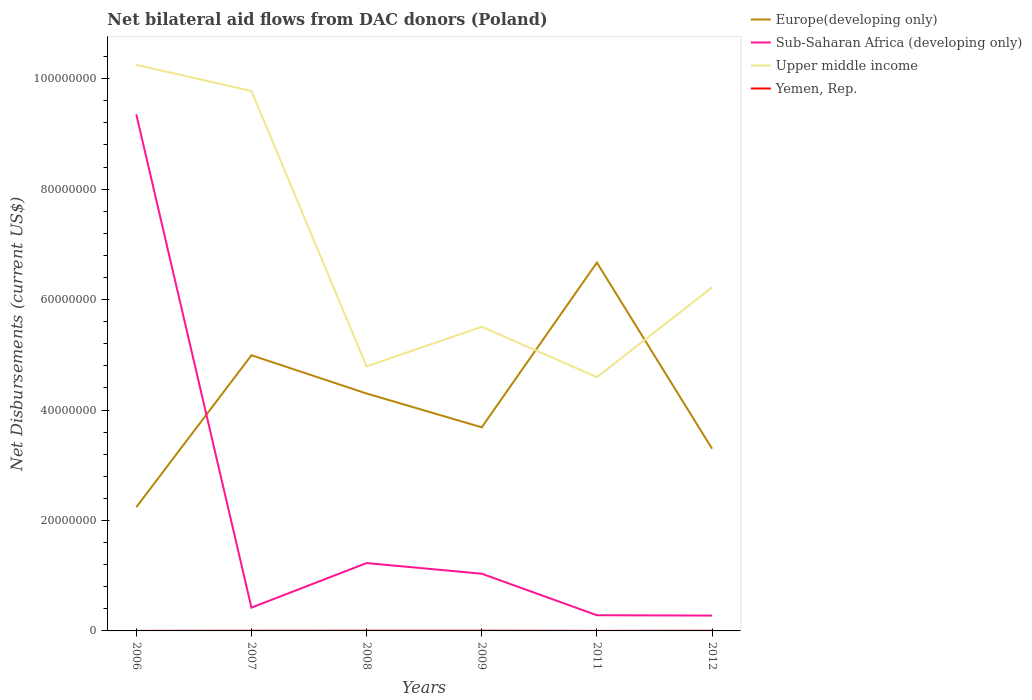How many different coloured lines are there?
Offer a very short reply. 4. Is the number of lines equal to the number of legend labels?
Offer a very short reply. Yes. Across all years, what is the maximum net bilateral aid flows in Sub-Saharan Africa (developing only)?
Your answer should be very brief. 2.78e+06. What is the total net bilateral aid flows in Europe(developing only) in the graph?
Offer a very short reply. -1.06e+07. What is the difference between the highest and the second highest net bilateral aid flows in Upper middle income?
Make the answer very short. 5.65e+07. Is the net bilateral aid flows in Sub-Saharan Africa (developing only) strictly greater than the net bilateral aid flows in Upper middle income over the years?
Ensure brevity in your answer.  Yes. How many lines are there?
Your answer should be compact. 4. What is the difference between two consecutive major ticks on the Y-axis?
Ensure brevity in your answer.  2.00e+07. Does the graph contain any zero values?
Your answer should be very brief. No. What is the title of the graph?
Offer a very short reply. Net bilateral aid flows from DAC donors (Poland). What is the label or title of the X-axis?
Offer a very short reply. Years. What is the label or title of the Y-axis?
Provide a succinct answer. Net Disbursements (current US$). What is the Net Disbursements (current US$) in Europe(developing only) in 2006?
Offer a very short reply. 2.24e+07. What is the Net Disbursements (current US$) in Sub-Saharan Africa (developing only) in 2006?
Provide a short and direct response. 9.35e+07. What is the Net Disbursements (current US$) of Upper middle income in 2006?
Your response must be concise. 1.02e+08. What is the Net Disbursements (current US$) in Europe(developing only) in 2007?
Provide a succinct answer. 4.99e+07. What is the Net Disbursements (current US$) of Sub-Saharan Africa (developing only) in 2007?
Your answer should be compact. 4.22e+06. What is the Net Disbursements (current US$) in Upper middle income in 2007?
Offer a terse response. 9.78e+07. What is the Net Disbursements (current US$) in Europe(developing only) in 2008?
Your answer should be compact. 4.30e+07. What is the Net Disbursements (current US$) in Sub-Saharan Africa (developing only) in 2008?
Offer a very short reply. 1.23e+07. What is the Net Disbursements (current US$) in Upper middle income in 2008?
Keep it short and to the point. 4.79e+07. What is the Net Disbursements (current US$) of Europe(developing only) in 2009?
Keep it short and to the point. 3.69e+07. What is the Net Disbursements (current US$) of Sub-Saharan Africa (developing only) in 2009?
Keep it short and to the point. 1.04e+07. What is the Net Disbursements (current US$) of Upper middle income in 2009?
Your answer should be very brief. 5.51e+07. What is the Net Disbursements (current US$) in Yemen, Rep. in 2009?
Offer a terse response. 4.00e+04. What is the Net Disbursements (current US$) of Europe(developing only) in 2011?
Provide a succinct answer. 6.67e+07. What is the Net Disbursements (current US$) in Sub-Saharan Africa (developing only) in 2011?
Offer a very short reply. 2.84e+06. What is the Net Disbursements (current US$) of Upper middle income in 2011?
Your answer should be very brief. 4.60e+07. What is the Net Disbursements (current US$) of Yemen, Rep. in 2011?
Offer a terse response. 10000. What is the Net Disbursements (current US$) of Europe(developing only) in 2012?
Make the answer very short. 3.30e+07. What is the Net Disbursements (current US$) of Sub-Saharan Africa (developing only) in 2012?
Provide a succinct answer. 2.78e+06. What is the Net Disbursements (current US$) of Upper middle income in 2012?
Your answer should be compact. 6.22e+07. What is the Net Disbursements (current US$) of Yemen, Rep. in 2012?
Make the answer very short. 3.00e+04. Across all years, what is the maximum Net Disbursements (current US$) of Europe(developing only)?
Offer a very short reply. 6.67e+07. Across all years, what is the maximum Net Disbursements (current US$) in Sub-Saharan Africa (developing only)?
Make the answer very short. 9.35e+07. Across all years, what is the maximum Net Disbursements (current US$) in Upper middle income?
Make the answer very short. 1.02e+08. Across all years, what is the minimum Net Disbursements (current US$) in Europe(developing only)?
Give a very brief answer. 2.24e+07. Across all years, what is the minimum Net Disbursements (current US$) in Sub-Saharan Africa (developing only)?
Offer a very short reply. 2.78e+06. Across all years, what is the minimum Net Disbursements (current US$) in Upper middle income?
Give a very brief answer. 4.60e+07. Across all years, what is the minimum Net Disbursements (current US$) in Yemen, Rep.?
Provide a short and direct response. 10000. What is the total Net Disbursements (current US$) of Europe(developing only) in the graph?
Your answer should be very brief. 2.52e+08. What is the total Net Disbursements (current US$) in Sub-Saharan Africa (developing only) in the graph?
Provide a short and direct response. 1.26e+08. What is the total Net Disbursements (current US$) in Upper middle income in the graph?
Make the answer very short. 4.11e+08. What is the difference between the Net Disbursements (current US$) in Europe(developing only) in 2006 and that in 2007?
Keep it short and to the point. -2.75e+07. What is the difference between the Net Disbursements (current US$) of Sub-Saharan Africa (developing only) in 2006 and that in 2007?
Your response must be concise. 8.93e+07. What is the difference between the Net Disbursements (current US$) of Upper middle income in 2006 and that in 2007?
Give a very brief answer. 4.73e+06. What is the difference between the Net Disbursements (current US$) of Europe(developing only) in 2006 and that in 2008?
Your response must be concise. -2.06e+07. What is the difference between the Net Disbursements (current US$) in Sub-Saharan Africa (developing only) in 2006 and that in 2008?
Offer a very short reply. 8.12e+07. What is the difference between the Net Disbursements (current US$) of Upper middle income in 2006 and that in 2008?
Your response must be concise. 5.46e+07. What is the difference between the Net Disbursements (current US$) in Yemen, Rep. in 2006 and that in 2008?
Provide a succinct answer. -3.00e+04. What is the difference between the Net Disbursements (current US$) of Europe(developing only) in 2006 and that in 2009?
Give a very brief answer. -1.45e+07. What is the difference between the Net Disbursements (current US$) in Sub-Saharan Africa (developing only) in 2006 and that in 2009?
Provide a short and direct response. 8.32e+07. What is the difference between the Net Disbursements (current US$) in Upper middle income in 2006 and that in 2009?
Your response must be concise. 4.74e+07. What is the difference between the Net Disbursements (current US$) of Yemen, Rep. in 2006 and that in 2009?
Offer a terse response. -3.00e+04. What is the difference between the Net Disbursements (current US$) in Europe(developing only) in 2006 and that in 2011?
Provide a short and direct response. -4.43e+07. What is the difference between the Net Disbursements (current US$) of Sub-Saharan Africa (developing only) in 2006 and that in 2011?
Provide a succinct answer. 9.07e+07. What is the difference between the Net Disbursements (current US$) of Upper middle income in 2006 and that in 2011?
Give a very brief answer. 5.65e+07. What is the difference between the Net Disbursements (current US$) of Europe(developing only) in 2006 and that in 2012?
Your response must be concise. -1.06e+07. What is the difference between the Net Disbursements (current US$) of Sub-Saharan Africa (developing only) in 2006 and that in 2012?
Make the answer very short. 9.08e+07. What is the difference between the Net Disbursements (current US$) in Upper middle income in 2006 and that in 2012?
Give a very brief answer. 4.03e+07. What is the difference between the Net Disbursements (current US$) of Yemen, Rep. in 2006 and that in 2012?
Provide a succinct answer. -2.00e+04. What is the difference between the Net Disbursements (current US$) of Europe(developing only) in 2007 and that in 2008?
Your answer should be compact. 6.93e+06. What is the difference between the Net Disbursements (current US$) of Sub-Saharan Africa (developing only) in 2007 and that in 2008?
Offer a terse response. -8.07e+06. What is the difference between the Net Disbursements (current US$) in Upper middle income in 2007 and that in 2008?
Offer a terse response. 4.99e+07. What is the difference between the Net Disbursements (current US$) of Yemen, Rep. in 2007 and that in 2008?
Provide a succinct answer. -10000. What is the difference between the Net Disbursements (current US$) in Europe(developing only) in 2007 and that in 2009?
Give a very brief answer. 1.30e+07. What is the difference between the Net Disbursements (current US$) in Sub-Saharan Africa (developing only) in 2007 and that in 2009?
Ensure brevity in your answer.  -6.14e+06. What is the difference between the Net Disbursements (current US$) of Upper middle income in 2007 and that in 2009?
Provide a short and direct response. 4.27e+07. What is the difference between the Net Disbursements (current US$) of Europe(developing only) in 2007 and that in 2011?
Keep it short and to the point. -1.68e+07. What is the difference between the Net Disbursements (current US$) of Sub-Saharan Africa (developing only) in 2007 and that in 2011?
Make the answer very short. 1.38e+06. What is the difference between the Net Disbursements (current US$) of Upper middle income in 2007 and that in 2011?
Give a very brief answer. 5.18e+07. What is the difference between the Net Disbursements (current US$) in Europe(developing only) in 2007 and that in 2012?
Offer a terse response. 1.69e+07. What is the difference between the Net Disbursements (current US$) in Sub-Saharan Africa (developing only) in 2007 and that in 2012?
Ensure brevity in your answer.  1.44e+06. What is the difference between the Net Disbursements (current US$) in Upper middle income in 2007 and that in 2012?
Provide a short and direct response. 3.56e+07. What is the difference between the Net Disbursements (current US$) of Europe(developing only) in 2008 and that in 2009?
Your answer should be very brief. 6.12e+06. What is the difference between the Net Disbursements (current US$) of Sub-Saharan Africa (developing only) in 2008 and that in 2009?
Make the answer very short. 1.93e+06. What is the difference between the Net Disbursements (current US$) of Upper middle income in 2008 and that in 2009?
Ensure brevity in your answer.  -7.17e+06. What is the difference between the Net Disbursements (current US$) of Europe(developing only) in 2008 and that in 2011?
Ensure brevity in your answer.  -2.37e+07. What is the difference between the Net Disbursements (current US$) of Sub-Saharan Africa (developing only) in 2008 and that in 2011?
Your response must be concise. 9.45e+06. What is the difference between the Net Disbursements (current US$) of Upper middle income in 2008 and that in 2011?
Provide a short and direct response. 1.94e+06. What is the difference between the Net Disbursements (current US$) in Yemen, Rep. in 2008 and that in 2011?
Keep it short and to the point. 3.00e+04. What is the difference between the Net Disbursements (current US$) in Europe(developing only) in 2008 and that in 2012?
Give a very brief answer. 9.99e+06. What is the difference between the Net Disbursements (current US$) in Sub-Saharan Africa (developing only) in 2008 and that in 2012?
Offer a very short reply. 9.51e+06. What is the difference between the Net Disbursements (current US$) of Upper middle income in 2008 and that in 2012?
Your response must be concise. -1.43e+07. What is the difference between the Net Disbursements (current US$) in Yemen, Rep. in 2008 and that in 2012?
Offer a terse response. 10000. What is the difference between the Net Disbursements (current US$) in Europe(developing only) in 2009 and that in 2011?
Offer a terse response. -2.98e+07. What is the difference between the Net Disbursements (current US$) in Sub-Saharan Africa (developing only) in 2009 and that in 2011?
Make the answer very short. 7.52e+06. What is the difference between the Net Disbursements (current US$) of Upper middle income in 2009 and that in 2011?
Provide a succinct answer. 9.11e+06. What is the difference between the Net Disbursements (current US$) of Europe(developing only) in 2009 and that in 2012?
Your answer should be compact. 3.87e+06. What is the difference between the Net Disbursements (current US$) in Sub-Saharan Africa (developing only) in 2009 and that in 2012?
Offer a very short reply. 7.58e+06. What is the difference between the Net Disbursements (current US$) of Upper middle income in 2009 and that in 2012?
Provide a short and direct response. -7.13e+06. What is the difference between the Net Disbursements (current US$) in Europe(developing only) in 2011 and that in 2012?
Give a very brief answer. 3.37e+07. What is the difference between the Net Disbursements (current US$) in Sub-Saharan Africa (developing only) in 2011 and that in 2012?
Your response must be concise. 6.00e+04. What is the difference between the Net Disbursements (current US$) in Upper middle income in 2011 and that in 2012?
Give a very brief answer. -1.62e+07. What is the difference between the Net Disbursements (current US$) in Yemen, Rep. in 2011 and that in 2012?
Provide a succinct answer. -2.00e+04. What is the difference between the Net Disbursements (current US$) in Europe(developing only) in 2006 and the Net Disbursements (current US$) in Sub-Saharan Africa (developing only) in 2007?
Give a very brief answer. 1.82e+07. What is the difference between the Net Disbursements (current US$) of Europe(developing only) in 2006 and the Net Disbursements (current US$) of Upper middle income in 2007?
Provide a short and direct response. -7.54e+07. What is the difference between the Net Disbursements (current US$) in Europe(developing only) in 2006 and the Net Disbursements (current US$) in Yemen, Rep. in 2007?
Your answer should be very brief. 2.24e+07. What is the difference between the Net Disbursements (current US$) in Sub-Saharan Africa (developing only) in 2006 and the Net Disbursements (current US$) in Upper middle income in 2007?
Give a very brief answer. -4.23e+06. What is the difference between the Net Disbursements (current US$) in Sub-Saharan Africa (developing only) in 2006 and the Net Disbursements (current US$) in Yemen, Rep. in 2007?
Your answer should be compact. 9.35e+07. What is the difference between the Net Disbursements (current US$) of Upper middle income in 2006 and the Net Disbursements (current US$) of Yemen, Rep. in 2007?
Your answer should be compact. 1.02e+08. What is the difference between the Net Disbursements (current US$) of Europe(developing only) in 2006 and the Net Disbursements (current US$) of Sub-Saharan Africa (developing only) in 2008?
Your response must be concise. 1.01e+07. What is the difference between the Net Disbursements (current US$) of Europe(developing only) in 2006 and the Net Disbursements (current US$) of Upper middle income in 2008?
Your answer should be compact. -2.55e+07. What is the difference between the Net Disbursements (current US$) in Europe(developing only) in 2006 and the Net Disbursements (current US$) in Yemen, Rep. in 2008?
Offer a terse response. 2.24e+07. What is the difference between the Net Disbursements (current US$) in Sub-Saharan Africa (developing only) in 2006 and the Net Disbursements (current US$) in Upper middle income in 2008?
Ensure brevity in your answer.  4.56e+07. What is the difference between the Net Disbursements (current US$) in Sub-Saharan Africa (developing only) in 2006 and the Net Disbursements (current US$) in Yemen, Rep. in 2008?
Provide a short and direct response. 9.35e+07. What is the difference between the Net Disbursements (current US$) in Upper middle income in 2006 and the Net Disbursements (current US$) in Yemen, Rep. in 2008?
Provide a succinct answer. 1.02e+08. What is the difference between the Net Disbursements (current US$) of Europe(developing only) in 2006 and the Net Disbursements (current US$) of Sub-Saharan Africa (developing only) in 2009?
Offer a terse response. 1.20e+07. What is the difference between the Net Disbursements (current US$) in Europe(developing only) in 2006 and the Net Disbursements (current US$) in Upper middle income in 2009?
Give a very brief answer. -3.27e+07. What is the difference between the Net Disbursements (current US$) of Europe(developing only) in 2006 and the Net Disbursements (current US$) of Yemen, Rep. in 2009?
Your answer should be very brief. 2.24e+07. What is the difference between the Net Disbursements (current US$) of Sub-Saharan Africa (developing only) in 2006 and the Net Disbursements (current US$) of Upper middle income in 2009?
Ensure brevity in your answer.  3.85e+07. What is the difference between the Net Disbursements (current US$) in Sub-Saharan Africa (developing only) in 2006 and the Net Disbursements (current US$) in Yemen, Rep. in 2009?
Keep it short and to the point. 9.35e+07. What is the difference between the Net Disbursements (current US$) in Upper middle income in 2006 and the Net Disbursements (current US$) in Yemen, Rep. in 2009?
Make the answer very short. 1.02e+08. What is the difference between the Net Disbursements (current US$) of Europe(developing only) in 2006 and the Net Disbursements (current US$) of Sub-Saharan Africa (developing only) in 2011?
Your response must be concise. 1.96e+07. What is the difference between the Net Disbursements (current US$) of Europe(developing only) in 2006 and the Net Disbursements (current US$) of Upper middle income in 2011?
Your answer should be compact. -2.36e+07. What is the difference between the Net Disbursements (current US$) in Europe(developing only) in 2006 and the Net Disbursements (current US$) in Yemen, Rep. in 2011?
Ensure brevity in your answer.  2.24e+07. What is the difference between the Net Disbursements (current US$) in Sub-Saharan Africa (developing only) in 2006 and the Net Disbursements (current US$) in Upper middle income in 2011?
Your answer should be very brief. 4.76e+07. What is the difference between the Net Disbursements (current US$) of Sub-Saharan Africa (developing only) in 2006 and the Net Disbursements (current US$) of Yemen, Rep. in 2011?
Your answer should be compact. 9.35e+07. What is the difference between the Net Disbursements (current US$) in Upper middle income in 2006 and the Net Disbursements (current US$) in Yemen, Rep. in 2011?
Provide a succinct answer. 1.02e+08. What is the difference between the Net Disbursements (current US$) in Europe(developing only) in 2006 and the Net Disbursements (current US$) in Sub-Saharan Africa (developing only) in 2012?
Your response must be concise. 1.96e+07. What is the difference between the Net Disbursements (current US$) of Europe(developing only) in 2006 and the Net Disbursements (current US$) of Upper middle income in 2012?
Your answer should be very brief. -3.98e+07. What is the difference between the Net Disbursements (current US$) of Europe(developing only) in 2006 and the Net Disbursements (current US$) of Yemen, Rep. in 2012?
Your answer should be compact. 2.24e+07. What is the difference between the Net Disbursements (current US$) in Sub-Saharan Africa (developing only) in 2006 and the Net Disbursements (current US$) in Upper middle income in 2012?
Provide a succinct answer. 3.13e+07. What is the difference between the Net Disbursements (current US$) of Sub-Saharan Africa (developing only) in 2006 and the Net Disbursements (current US$) of Yemen, Rep. in 2012?
Keep it short and to the point. 9.35e+07. What is the difference between the Net Disbursements (current US$) of Upper middle income in 2006 and the Net Disbursements (current US$) of Yemen, Rep. in 2012?
Make the answer very short. 1.02e+08. What is the difference between the Net Disbursements (current US$) in Europe(developing only) in 2007 and the Net Disbursements (current US$) in Sub-Saharan Africa (developing only) in 2008?
Make the answer very short. 3.76e+07. What is the difference between the Net Disbursements (current US$) in Europe(developing only) in 2007 and the Net Disbursements (current US$) in Upper middle income in 2008?
Your answer should be compact. 2.02e+06. What is the difference between the Net Disbursements (current US$) in Europe(developing only) in 2007 and the Net Disbursements (current US$) in Yemen, Rep. in 2008?
Provide a short and direct response. 4.99e+07. What is the difference between the Net Disbursements (current US$) of Sub-Saharan Africa (developing only) in 2007 and the Net Disbursements (current US$) of Upper middle income in 2008?
Ensure brevity in your answer.  -4.37e+07. What is the difference between the Net Disbursements (current US$) in Sub-Saharan Africa (developing only) in 2007 and the Net Disbursements (current US$) in Yemen, Rep. in 2008?
Provide a short and direct response. 4.18e+06. What is the difference between the Net Disbursements (current US$) in Upper middle income in 2007 and the Net Disbursements (current US$) in Yemen, Rep. in 2008?
Keep it short and to the point. 9.77e+07. What is the difference between the Net Disbursements (current US$) of Europe(developing only) in 2007 and the Net Disbursements (current US$) of Sub-Saharan Africa (developing only) in 2009?
Provide a succinct answer. 3.96e+07. What is the difference between the Net Disbursements (current US$) of Europe(developing only) in 2007 and the Net Disbursements (current US$) of Upper middle income in 2009?
Give a very brief answer. -5.15e+06. What is the difference between the Net Disbursements (current US$) of Europe(developing only) in 2007 and the Net Disbursements (current US$) of Yemen, Rep. in 2009?
Provide a succinct answer. 4.99e+07. What is the difference between the Net Disbursements (current US$) in Sub-Saharan Africa (developing only) in 2007 and the Net Disbursements (current US$) in Upper middle income in 2009?
Offer a very short reply. -5.08e+07. What is the difference between the Net Disbursements (current US$) in Sub-Saharan Africa (developing only) in 2007 and the Net Disbursements (current US$) in Yemen, Rep. in 2009?
Offer a terse response. 4.18e+06. What is the difference between the Net Disbursements (current US$) of Upper middle income in 2007 and the Net Disbursements (current US$) of Yemen, Rep. in 2009?
Give a very brief answer. 9.77e+07. What is the difference between the Net Disbursements (current US$) in Europe(developing only) in 2007 and the Net Disbursements (current US$) in Sub-Saharan Africa (developing only) in 2011?
Ensure brevity in your answer.  4.71e+07. What is the difference between the Net Disbursements (current US$) of Europe(developing only) in 2007 and the Net Disbursements (current US$) of Upper middle income in 2011?
Provide a succinct answer. 3.96e+06. What is the difference between the Net Disbursements (current US$) in Europe(developing only) in 2007 and the Net Disbursements (current US$) in Yemen, Rep. in 2011?
Provide a short and direct response. 4.99e+07. What is the difference between the Net Disbursements (current US$) in Sub-Saharan Africa (developing only) in 2007 and the Net Disbursements (current US$) in Upper middle income in 2011?
Offer a terse response. -4.17e+07. What is the difference between the Net Disbursements (current US$) in Sub-Saharan Africa (developing only) in 2007 and the Net Disbursements (current US$) in Yemen, Rep. in 2011?
Give a very brief answer. 4.21e+06. What is the difference between the Net Disbursements (current US$) in Upper middle income in 2007 and the Net Disbursements (current US$) in Yemen, Rep. in 2011?
Offer a very short reply. 9.78e+07. What is the difference between the Net Disbursements (current US$) in Europe(developing only) in 2007 and the Net Disbursements (current US$) in Sub-Saharan Africa (developing only) in 2012?
Your answer should be compact. 4.71e+07. What is the difference between the Net Disbursements (current US$) in Europe(developing only) in 2007 and the Net Disbursements (current US$) in Upper middle income in 2012?
Offer a very short reply. -1.23e+07. What is the difference between the Net Disbursements (current US$) of Europe(developing only) in 2007 and the Net Disbursements (current US$) of Yemen, Rep. in 2012?
Ensure brevity in your answer.  4.99e+07. What is the difference between the Net Disbursements (current US$) of Sub-Saharan Africa (developing only) in 2007 and the Net Disbursements (current US$) of Upper middle income in 2012?
Offer a terse response. -5.80e+07. What is the difference between the Net Disbursements (current US$) in Sub-Saharan Africa (developing only) in 2007 and the Net Disbursements (current US$) in Yemen, Rep. in 2012?
Your answer should be compact. 4.19e+06. What is the difference between the Net Disbursements (current US$) of Upper middle income in 2007 and the Net Disbursements (current US$) of Yemen, Rep. in 2012?
Your response must be concise. 9.77e+07. What is the difference between the Net Disbursements (current US$) of Europe(developing only) in 2008 and the Net Disbursements (current US$) of Sub-Saharan Africa (developing only) in 2009?
Your answer should be very brief. 3.26e+07. What is the difference between the Net Disbursements (current US$) in Europe(developing only) in 2008 and the Net Disbursements (current US$) in Upper middle income in 2009?
Make the answer very short. -1.21e+07. What is the difference between the Net Disbursements (current US$) of Europe(developing only) in 2008 and the Net Disbursements (current US$) of Yemen, Rep. in 2009?
Your answer should be very brief. 4.30e+07. What is the difference between the Net Disbursements (current US$) of Sub-Saharan Africa (developing only) in 2008 and the Net Disbursements (current US$) of Upper middle income in 2009?
Your answer should be very brief. -4.28e+07. What is the difference between the Net Disbursements (current US$) in Sub-Saharan Africa (developing only) in 2008 and the Net Disbursements (current US$) in Yemen, Rep. in 2009?
Make the answer very short. 1.22e+07. What is the difference between the Net Disbursements (current US$) of Upper middle income in 2008 and the Net Disbursements (current US$) of Yemen, Rep. in 2009?
Provide a short and direct response. 4.79e+07. What is the difference between the Net Disbursements (current US$) of Europe(developing only) in 2008 and the Net Disbursements (current US$) of Sub-Saharan Africa (developing only) in 2011?
Offer a very short reply. 4.02e+07. What is the difference between the Net Disbursements (current US$) of Europe(developing only) in 2008 and the Net Disbursements (current US$) of Upper middle income in 2011?
Your response must be concise. -2.97e+06. What is the difference between the Net Disbursements (current US$) in Europe(developing only) in 2008 and the Net Disbursements (current US$) in Yemen, Rep. in 2011?
Your response must be concise. 4.30e+07. What is the difference between the Net Disbursements (current US$) of Sub-Saharan Africa (developing only) in 2008 and the Net Disbursements (current US$) of Upper middle income in 2011?
Give a very brief answer. -3.37e+07. What is the difference between the Net Disbursements (current US$) in Sub-Saharan Africa (developing only) in 2008 and the Net Disbursements (current US$) in Yemen, Rep. in 2011?
Provide a short and direct response. 1.23e+07. What is the difference between the Net Disbursements (current US$) of Upper middle income in 2008 and the Net Disbursements (current US$) of Yemen, Rep. in 2011?
Provide a succinct answer. 4.79e+07. What is the difference between the Net Disbursements (current US$) of Europe(developing only) in 2008 and the Net Disbursements (current US$) of Sub-Saharan Africa (developing only) in 2012?
Make the answer very short. 4.02e+07. What is the difference between the Net Disbursements (current US$) in Europe(developing only) in 2008 and the Net Disbursements (current US$) in Upper middle income in 2012?
Provide a short and direct response. -1.92e+07. What is the difference between the Net Disbursements (current US$) in Europe(developing only) in 2008 and the Net Disbursements (current US$) in Yemen, Rep. in 2012?
Provide a succinct answer. 4.30e+07. What is the difference between the Net Disbursements (current US$) in Sub-Saharan Africa (developing only) in 2008 and the Net Disbursements (current US$) in Upper middle income in 2012?
Provide a succinct answer. -4.99e+07. What is the difference between the Net Disbursements (current US$) in Sub-Saharan Africa (developing only) in 2008 and the Net Disbursements (current US$) in Yemen, Rep. in 2012?
Your answer should be compact. 1.23e+07. What is the difference between the Net Disbursements (current US$) in Upper middle income in 2008 and the Net Disbursements (current US$) in Yemen, Rep. in 2012?
Provide a short and direct response. 4.79e+07. What is the difference between the Net Disbursements (current US$) of Europe(developing only) in 2009 and the Net Disbursements (current US$) of Sub-Saharan Africa (developing only) in 2011?
Ensure brevity in your answer.  3.40e+07. What is the difference between the Net Disbursements (current US$) in Europe(developing only) in 2009 and the Net Disbursements (current US$) in Upper middle income in 2011?
Provide a succinct answer. -9.09e+06. What is the difference between the Net Disbursements (current US$) of Europe(developing only) in 2009 and the Net Disbursements (current US$) of Yemen, Rep. in 2011?
Ensure brevity in your answer.  3.69e+07. What is the difference between the Net Disbursements (current US$) in Sub-Saharan Africa (developing only) in 2009 and the Net Disbursements (current US$) in Upper middle income in 2011?
Offer a terse response. -3.56e+07. What is the difference between the Net Disbursements (current US$) in Sub-Saharan Africa (developing only) in 2009 and the Net Disbursements (current US$) in Yemen, Rep. in 2011?
Make the answer very short. 1.04e+07. What is the difference between the Net Disbursements (current US$) of Upper middle income in 2009 and the Net Disbursements (current US$) of Yemen, Rep. in 2011?
Give a very brief answer. 5.51e+07. What is the difference between the Net Disbursements (current US$) in Europe(developing only) in 2009 and the Net Disbursements (current US$) in Sub-Saharan Africa (developing only) in 2012?
Provide a succinct answer. 3.41e+07. What is the difference between the Net Disbursements (current US$) in Europe(developing only) in 2009 and the Net Disbursements (current US$) in Upper middle income in 2012?
Keep it short and to the point. -2.53e+07. What is the difference between the Net Disbursements (current US$) of Europe(developing only) in 2009 and the Net Disbursements (current US$) of Yemen, Rep. in 2012?
Ensure brevity in your answer.  3.68e+07. What is the difference between the Net Disbursements (current US$) of Sub-Saharan Africa (developing only) in 2009 and the Net Disbursements (current US$) of Upper middle income in 2012?
Give a very brief answer. -5.18e+07. What is the difference between the Net Disbursements (current US$) of Sub-Saharan Africa (developing only) in 2009 and the Net Disbursements (current US$) of Yemen, Rep. in 2012?
Keep it short and to the point. 1.03e+07. What is the difference between the Net Disbursements (current US$) of Upper middle income in 2009 and the Net Disbursements (current US$) of Yemen, Rep. in 2012?
Provide a succinct answer. 5.50e+07. What is the difference between the Net Disbursements (current US$) in Europe(developing only) in 2011 and the Net Disbursements (current US$) in Sub-Saharan Africa (developing only) in 2012?
Offer a very short reply. 6.39e+07. What is the difference between the Net Disbursements (current US$) of Europe(developing only) in 2011 and the Net Disbursements (current US$) of Upper middle income in 2012?
Offer a very short reply. 4.50e+06. What is the difference between the Net Disbursements (current US$) of Europe(developing only) in 2011 and the Net Disbursements (current US$) of Yemen, Rep. in 2012?
Your response must be concise. 6.67e+07. What is the difference between the Net Disbursements (current US$) in Sub-Saharan Africa (developing only) in 2011 and the Net Disbursements (current US$) in Upper middle income in 2012?
Provide a succinct answer. -5.94e+07. What is the difference between the Net Disbursements (current US$) in Sub-Saharan Africa (developing only) in 2011 and the Net Disbursements (current US$) in Yemen, Rep. in 2012?
Your response must be concise. 2.81e+06. What is the difference between the Net Disbursements (current US$) in Upper middle income in 2011 and the Net Disbursements (current US$) in Yemen, Rep. in 2012?
Ensure brevity in your answer.  4.59e+07. What is the average Net Disbursements (current US$) of Europe(developing only) per year?
Your answer should be compact. 4.20e+07. What is the average Net Disbursements (current US$) of Sub-Saharan Africa (developing only) per year?
Give a very brief answer. 2.10e+07. What is the average Net Disbursements (current US$) in Upper middle income per year?
Provide a short and direct response. 6.86e+07. What is the average Net Disbursements (current US$) of Yemen, Rep. per year?
Provide a short and direct response. 2.67e+04. In the year 2006, what is the difference between the Net Disbursements (current US$) in Europe(developing only) and Net Disbursements (current US$) in Sub-Saharan Africa (developing only)?
Keep it short and to the point. -7.11e+07. In the year 2006, what is the difference between the Net Disbursements (current US$) in Europe(developing only) and Net Disbursements (current US$) in Upper middle income?
Your answer should be very brief. -8.01e+07. In the year 2006, what is the difference between the Net Disbursements (current US$) in Europe(developing only) and Net Disbursements (current US$) in Yemen, Rep.?
Keep it short and to the point. 2.24e+07. In the year 2006, what is the difference between the Net Disbursements (current US$) in Sub-Saharan Africa (developing only) and Net Disbursements (current US$) in Upper middle income?
Offer a terse response. -8.96e+06. In the year 2006, what is the difference between the Net Disbursements (current US$) in Sub-Saharan Africa (developing only) and Net Disbursements (current US$) in Yemen, Rep.?
Ensure brevity in your answer.  9.35e+07. In the year 2006, what is the difference between the Net Disbursements (current US$) of Upper middle income and Net Disbursements (current US$) of Yemen, Rep.?
Your answer should be compact. 1.02e+08. In the year 2007, what is the difference between the Net Disbursements (current US$) in Europe(developing only) and Net Disbursements (current US$) in Sub-Saharan Africa (developing only)?
Provide a succinct answer. 4.57e+07. In the year 2007, what is the difference between the Net Disbursements (current US$) of Europe(developing only) and Net Disbursements (current US$) of Upper middle income?
Your response must be concise. -4.78e+07. In the year 2007, what is the difference between the Net Disbursements (current US$) of Europe(developing only) and Net Disbursements (current US$) of Yemen, Rep.?
Ensure brevity in your answer.  4.99e+07. In the year 2007, what is the difference between the Net Disbursements (current US$) of Sub-Saharan Africa (developing only) and Net Disbursements (current US$) of Upper middle income?
Offer a very short reply. -9.36e+07. In the year 2007, what is the difference between the Net Disbursements (current US$) of Sub-Saharan Africa (developing only) and Net Disbursements (current US$) of Yemen, Rep.?
Your answer should be very brief. 4.19e+06. In the year 2007, what is the difference between the Net Disbursements (current US$) of Upper middle income and Net Disbursements (current US$) of Yemen, Rep.?
Give a very brief answer. 9.77e+07. In the year 2008, what is the difference between the Net Disbursements (current US$) of Europe(developing only) and Net Disbursements (current US$) of Sub-Saharan Africa (developing only)?
Ensure brevity in your answer.  3.07e+07. In the year 2008, what is the difference between the Net Disbursements (current US$) of Europe(developing only) and Net Disbursements (current US$) of Upper middle income?
Your answer should be very brief. -4.91e+06. In the year 2008, what is the difference between the Net Disbursements (current US$) in Europe(developing only) and Net Disbursements (current US$) in Yemen, Rep.?
Offer a terse response. 4.30e+07. In the year 2008, what is the difference between the Net Disbursements (current US$) of Sub-Saharan Africa (developing only) and Net Disbursements (current US$) of Upper middle income?
Provide a succinct answer. -3.56e+07. In the year 2008, what is the difference between the Net Disbursements (current US$) of Sub-Saharan Africa (developing only) and Net Disbursements (current US$) of Yemen, Rep.?
Keep it short and to the point. 1.22e+07. In the year 2008, what is the difference between the Net Disbursements (current US$) in Upper middle income and Net Disbursements (current US$) in Yemen, Rep.?
Provide a succinct answer. 4.79e+07. In the year 2009, what is the difference between the Net Disbursements (current US$) in Europe(developing only) and Net Disbursements (current US$) in Sub-Saharan Africa (developing only)?
Offer a terse response. 2.65e+07. In the year 2009, what is the difference between the Net Disbursements (current US$) of Europe(developing only) and Net Disbursements (current US$) of Upper middle income?
Your answer should be very brief. -1.82e+07. In the year 2009, what is the difference between the Net Disbursements (current US$) in Europe(developing only) and Net Disbursements (current US$) in Yemen, Rep.?
Keep it short and to the point. 3.68e+07. In the year 2009, what is the difference between the Net Disbursements (current US$) in Sub-Saharan Africa (developing only) and Net Disbursements (current US$) in Upper middle income?
Your response must be concise. -4.47e+07. In the year 2009, what is the difference between the Net Disbursements (current US$) in Sub-Saharan Africa (developing only) and Net Disbursements (current US$) in Yemen, Rep.?
Your answer should be compact. 1.03e+07. In the year 2009, what is the difference between the Net Disbursements (current US$) in Upper middle income and Net Disbursements (current US$) in Yemen, Rep.?
Offer a terse response. 5.50e+07. In the year 2011, what is the difference between the Net Disbursements (current US$) in Europe(developing only) and Net Disbursements (current US$) in Sub-Saharan Africa (developing only)?
Offer a very short reply. 6.39e+07. In the year 2011, what is the difference between the Net Disbursements (current US$) in Europe(developing only) and Net Disbursements (current US$) in Upper middle income?
Your answer should be very brief. 2.07e+07. In the year 2011, what is the difference between the Net Disbursements (current US$) in Europe(developing only) and Net Disbursements (current US$) in Yemen, Rep.?
Ensure brevity in your answer.  6.67e+07. In the year 2011, what is the difference between the Net Disbursements (current US$) in Sub-Saharan Africa (developing only) and Net Disbursements (current US$) in Upper middle income?
Your answer should be compact. -4.31e+07. In the year 2011, what is the difference between the Net Disbursements (current US$) in Sub-Saharan Africa (developing only) and Net Disbursements (current US$) in Yemen, Rep.?
Provide a short and direct response. 2.83e+06. In the year 2011, what is the difference between the Net Disbursements (current US$) of Upper middle income and Net Disbursements (current US$) of Yemen, Rep.?
Keep it short and to the point. 4.60e+07. In the year 2012, what is the difference between the Net Disbursements (current US$) in Europe(developing only) and Net Disbursements (current US$) in Sub-Saharan Africa (developing only)?
Your answer should be very brief. 3.02e+07. In the year 2012, what is the difference between the Net Disbursements (current US$) in Europe(developing only) and Net Disbursements (current US$) in Upper middle income?
Provide a short and direct response. -2.92e+07. In the year 2012, what is the difference between the Net Disbursements (current US$) in Europe(developing only) and Net Disbursements (current US$) in Yemen, Rep.?
Make the answer very short. 3.30e+07. In the year 2012, what is the difference between the Net Disbursements (current US$) of Sub-Saharan Africa (developing only) and Net Disbursements (current US$) of Upper middle income?
Give a very brief answer. -5.94e+07. In the year 2012, what is the difference between the Net Disbursements (current US$) of Sub-Saharan Africa (developing only) and Net Disbursements (current US$) of Yemen, Rep.?
Offer a very short reply. 2.75e+06. In the year 2012, what is the difference between the Net Disbursements (current US$) of Upper middle income and Net Disbursements (current US$) of Yemen, Rep.?
Ensure brevity in your answer.  6.22e+07. What is the ratio of the Net Disbursements (current US$) in Europe(developing only) in 2006 to that in 2007?
Provide a succinct answer. 0.45. What is the ratio of the Net Disbursements (current US$) of Sub-Saharan Africa (developing only) in 2006 to that in 2007?
Offer a very short reply. 22.17. What is the ratio of the Net Disbursements (current US$) of Upper middle income in 2006 to that in 2007?
Keep it short and to the point. 1.05. What is the ratio of the Net Disbursements (current US$) in Yemen, Rep. in 2006 to that in 2007?
Your response must be concise. 0.33. What is the ratio of the Net Disbursements (current US$) in Europe(developing only) in 2006 to that in 2008?
Keep it short and to the point. 0.52. What is the ratio of the Net Disbursements (current US$) in Sub-Saharan Africa (developing only) in 2006 to that in 2008?
Ensure brevity in your answer.  7.61. What is the ratio of the Net Disbursements (current US$) in Upper middle income in 2006 to that in 2008?
Offer a terse response. 2.14. What is the ratio of the Net Disbursements (current US$) in Europe(developing only) in 2006 to that in 2009?
Provide a short and direct response. 0.61. What is the ratio of the Net Disbursements (current US$) in Sub-Saharan Africa (developing only) in 2006 to that in 2009?
Your answer should be very brief. 9.03. What is the ratio of the Net Disbursements (current US$) of Upper middle income in 2006 to that in 2009?
Provide a succinct answer. 1.86. What is the ratio of the Net Disbursements (current US$) of Europe(developing only) in 2006 to that in 2011?
Provide a succinct answer. 0.34. What is the ratio of the Net Disbursements (current US$) in Sub-Saharan Africa (developing only) in 2006 to that in 2011?
Ensure brevity in your answer.  32.94. What is the ratio of the Net Disbursements (current US$) of Upper middle income in 2006 to that in 2011?
Give a very brief answer. 2.23. What is the ratio of the Net Disbursements (current US$) in Yemen, Rep. in 2006 to that in 2011?
Make the answer very short. 1. What is the ratio of the Net Disbursements (current US$) in Europe(developing only) in 2006 to that in 2012?
Offer a terse response. 0.68. What is the ratio of the Net Disbursements (current US$) of Sub-Saharan Africa (developing only) in 2006 to that in 2012?
Provide a succinct answer. 33.65. What is the ratio of the Net Disbursements (current US$) of Upper middle income in 2006 to that in 2012?
Make the answer very short. 1.65. What is the ratio of the Net Disbursements (current US$) of Yemen, Rep. in 2006 to that in 2012?
Provide a succinct answer. 0.33. What is the ratio of the Net Disbursements (current US$) of Europe(developing only) in 2007 to that in 2008?
Ensure brevity in your answer.  1.16. What is the ratio of the Net Disbursements (current US$) of Sub-Saharan Africa (developing only) in 2007 to that in 2008?
Give a very brief answer. 0.34. What is the ratio of the Net Disbursements (current US$) in Upper middle income in 2007 to that in 2008?
Provide a short and direct response. 2.04. What is the ratio of the Net Disbursements (current US$) of Yemen, Rep. in 2007 to that in 2008?
Keep it short and to the point. 0.75. What is the ratio of the Net Disbursements (current US$) in Europe(developing only) in 2007 to that in 2009?
Keep it short and to the point. 1.35. What is the ratio of the Net Disbursements (current US$) in Sub-Saharan Africa (developing only) in 2007 to that in 2009?
Your response must be concise. 0.41. What is the ratio of the Net Disbursements (current US$) in Upper middle income in 2007 to that in 2009?
Offer a very short reply. 1.78. What is the ratio of the Net Disbursements (current US$) of Europe(developing only) in 2007 to that in 2011?
Provide a succinct answer. 0.75. What is the ratio of the Net Disbursements (current US$) in Sub-Saharan Africa (developing only) in 2007 to that in 2011?
Offer a very short reply. 1.49. What is the ratio of the Net Disbursements (current US$) of Upper middle income in 2007 to that in 2011?
Provide a short and direct response. 2.13. What is the ratio of the Net Disbursements (current US$) of Yemen, Rep. in 2007 to that in 2011?
Your response must be concise. 3. What is the ratio of the Net Disbursements (current US$) of Europe(developing only) in 2007 to that in 2012?
Offer a terse response. 1.51. What is the ratio of the Net Disbursements (current US$) of Sub-Saharan Africa (developing only) in 2007 to that in 2012?
Ensure brevity in your answer.  1.52. What is the ratio of the Net Disbursements (current US$) of Upper middle income in 2007 to that in 2012?
Provide a succinct answer. 1.57. What is the ratio of the Net Disbursements (current US$) of Europe(developing only) in 2008 to that in 2009?
Offer a very short reply. 1.17. What is the ratio of the Net Disbursements (current US$) of Sub-Saharan Africa (developing only) in 2008 to that in 2009?
Provide a short and direct response. 1.19. What is the ratio of the Net Disbursements (current US$) of Upper middle income in 2008 to that in 2009?
Offer a terse response. 0.87. What is the ratio of the Net Disbursements (current US$) in Yemen, Rep. in 2008 to that in 2009?
Offer a terse response. 1. What is the ratio of the Net Disbursements (current US$) in Europe(developing only) in 2008 to that in 2011?
Your answer should be very brief. 0.64. What is the ratio of the Net Disbursements (current US$) of Sub-Saharan Africa (developing only) in 2008 to that in 2011?
Keep it short and to the point. 4.33. What is the ratio of the Net Disbursements (current US$) of Upper middle income in 2008 to that in 2011?
Provide a short and direct response. 1.04. What is the ratio of the Net Disbursements (current US$) in Yemen, Rep. in 2008 to that in 2011?
Keep it short and to the point. 4. What is the ratio of the Net Disbursements (current US$) of Europe(developing only) in 2008 to that in 2012?
Your answer should be very brief. 1.3. What is the ratio of the Net Disbursements (current US$) of Sub-Saharan Africa (developing only) in 2008 to that in 2012?
Make the answer very short. 4.42. What is the ratio of the Net Disbursements (current US$) in Upper middle income in 2008 to that in 2012?
Provide a short and direct response. 0.77. What is the ratio of the Net Disbursements (current US$) of Yemen, Rep. in 2008 to that in 2012?
Provide a short and direct response. 1.33. What is the ratio of the Net Disbursements (current US$) of Europe(developing only) in 2009 to that in 2011?
Your answer should be very brief. 0.55. What is the ratio of the Net Disbursements (current US$) in Sub-Saharan Africa (developing only) in 2009 to that in 2011?
Your answer should be compact. 3.65. What is the ratio of the Net Disbursements (current US$) in Upper middle income in 2009 to that in 2011?
Provide a succinct answer. 1.2. What is the ratio of the Net Disbursements (current US$) of Yemen, Rep. in 2009 to that in 2011?
Ensure brevity in your answer.  4. What is the ratio of the Net Disbursements (current US$) in Europe(developing only) in 2009 to that in 2012?
Give a very brief answer. 1.12. What is the ratio of the Net Disbursements (current US$) of Sub-Saharan Africa (developing only) in 2009 to that in 2012?
Ensure brevity in your answer.  3.73. What is the ratio of the Net Disbursements (current US$) in Upper middle income in 2009 to that in 2012?
Ensure brevity in your answer.  0.89. What is the ratio of the Net Disbursements (current US$) of Yemen, Rep. in 2009 to that in 2012?
Offer a terse response. 1.33. What is the ratio of the Net Disbursements (current US$) of Europe(developing only) in 2011 to that in 2012?
Give a very brief answer. 2.02. What is the ratio of the Net Disbursements (current US$) of Sub-Saharan Africa (developing only) in 2011 to that in 2012?
Your answer should be very brief. 1.02. What is the ratio of the Net Disbursements (current US$) in Upper middle income in 2011 to that in 2012?
Provide a succinct answer. 0.74. What is the difference between the highest and the second highest Net Disbursements (current US$) in Europe(developing only)?
Give a very brief answer. 1.68e+07. What is the difference between the highest and the second highest Net Disbursements (current US$) in Sub-Saharan Africa (developing only)?
Offer a very short reply. 8.12e+07. What is the difference between the highest and the second highest Net Disbursements (current US$) in Upper middle income?
Your answer should be compact. 4.73e+06. What is the difference between the highest and the second highest Net Disbursements (current US$) in Yemen, Rep.?
Keep it short and to the point. 0. What is the difference between the highest and the lowest Net Disbursements (current US$) in Europe(developing only)?
Offer a terse response. 4.43e+07. What is the difference between the highest and the lowest Net Disbursements (current US$) of Sub-Saharan Africa (developing only)?
Provide a succinct answer. 9.08e+07. What is the difference between the highest and the lowest Net Disbursements (current US$) in Upper middle income?
Provide a succinct answer. 5.65e+07. What is the difference between the highest and the lowest Net Disbursements (current US$) of Yemen, Rep.?
Provide a short and direct response. 3.00e+04. 